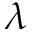Convert formula to latex. <formula><loc_0><loc_0><loc_500><loc_500>\lambda</formula> 